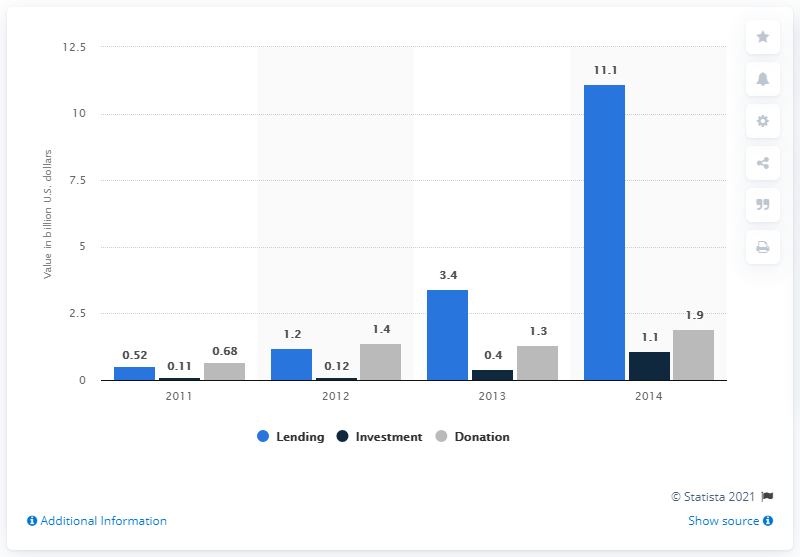Indicate a few pertinent items in this graphic. In 2013, the amount of funds raised through crowdfunding was 1.3 billion dollars. 